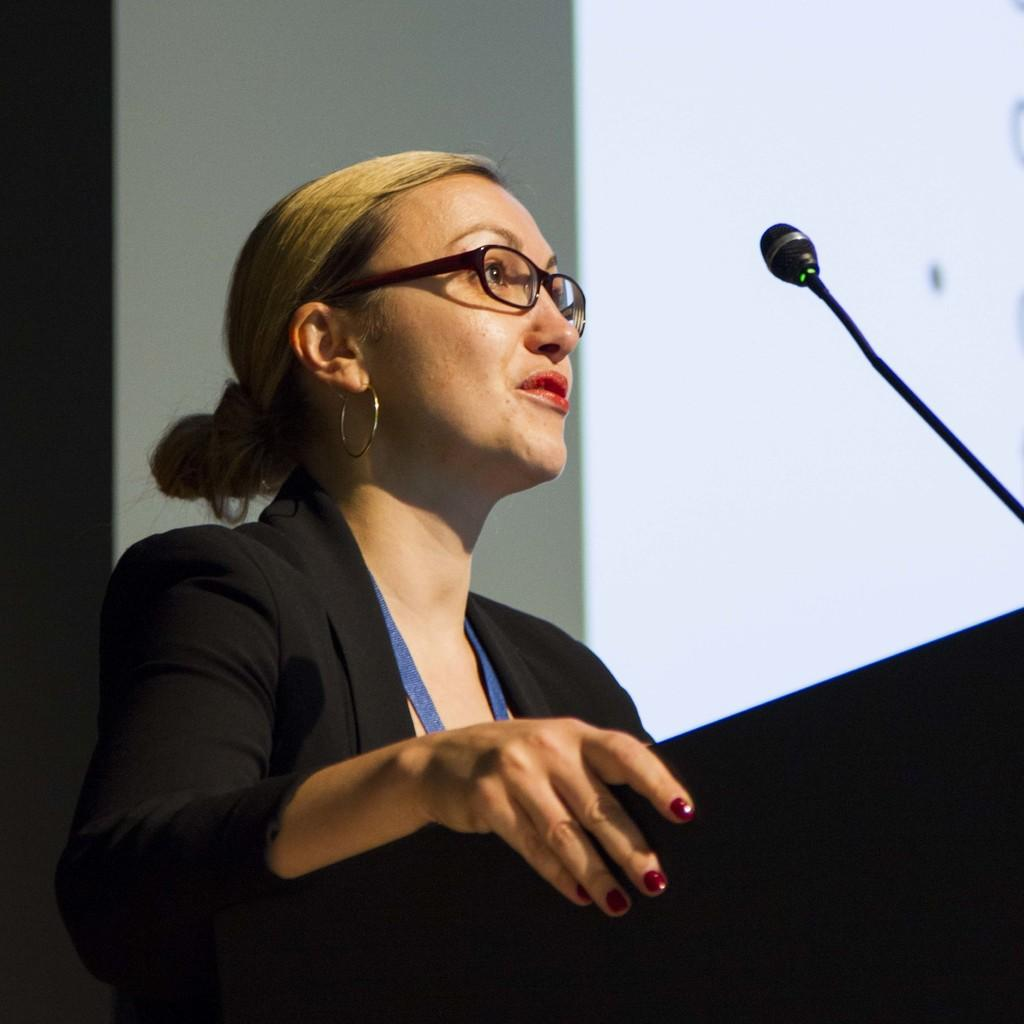Who is the main subject in the image? There is a woman in the image. What is the woman wearing? The woman is wearing a black coat. What object is in front of the woman? There is a podium in front of the woman. Where is the mic located in the image? The mic is on the right side of the image. What type of produce is the woman holding in the image? There is no produce present in the image; the woman is not holding any fruits or vegetables. What role does the actor play in the image? There is no actor mentioned in the image, as the main subject is a woman. 